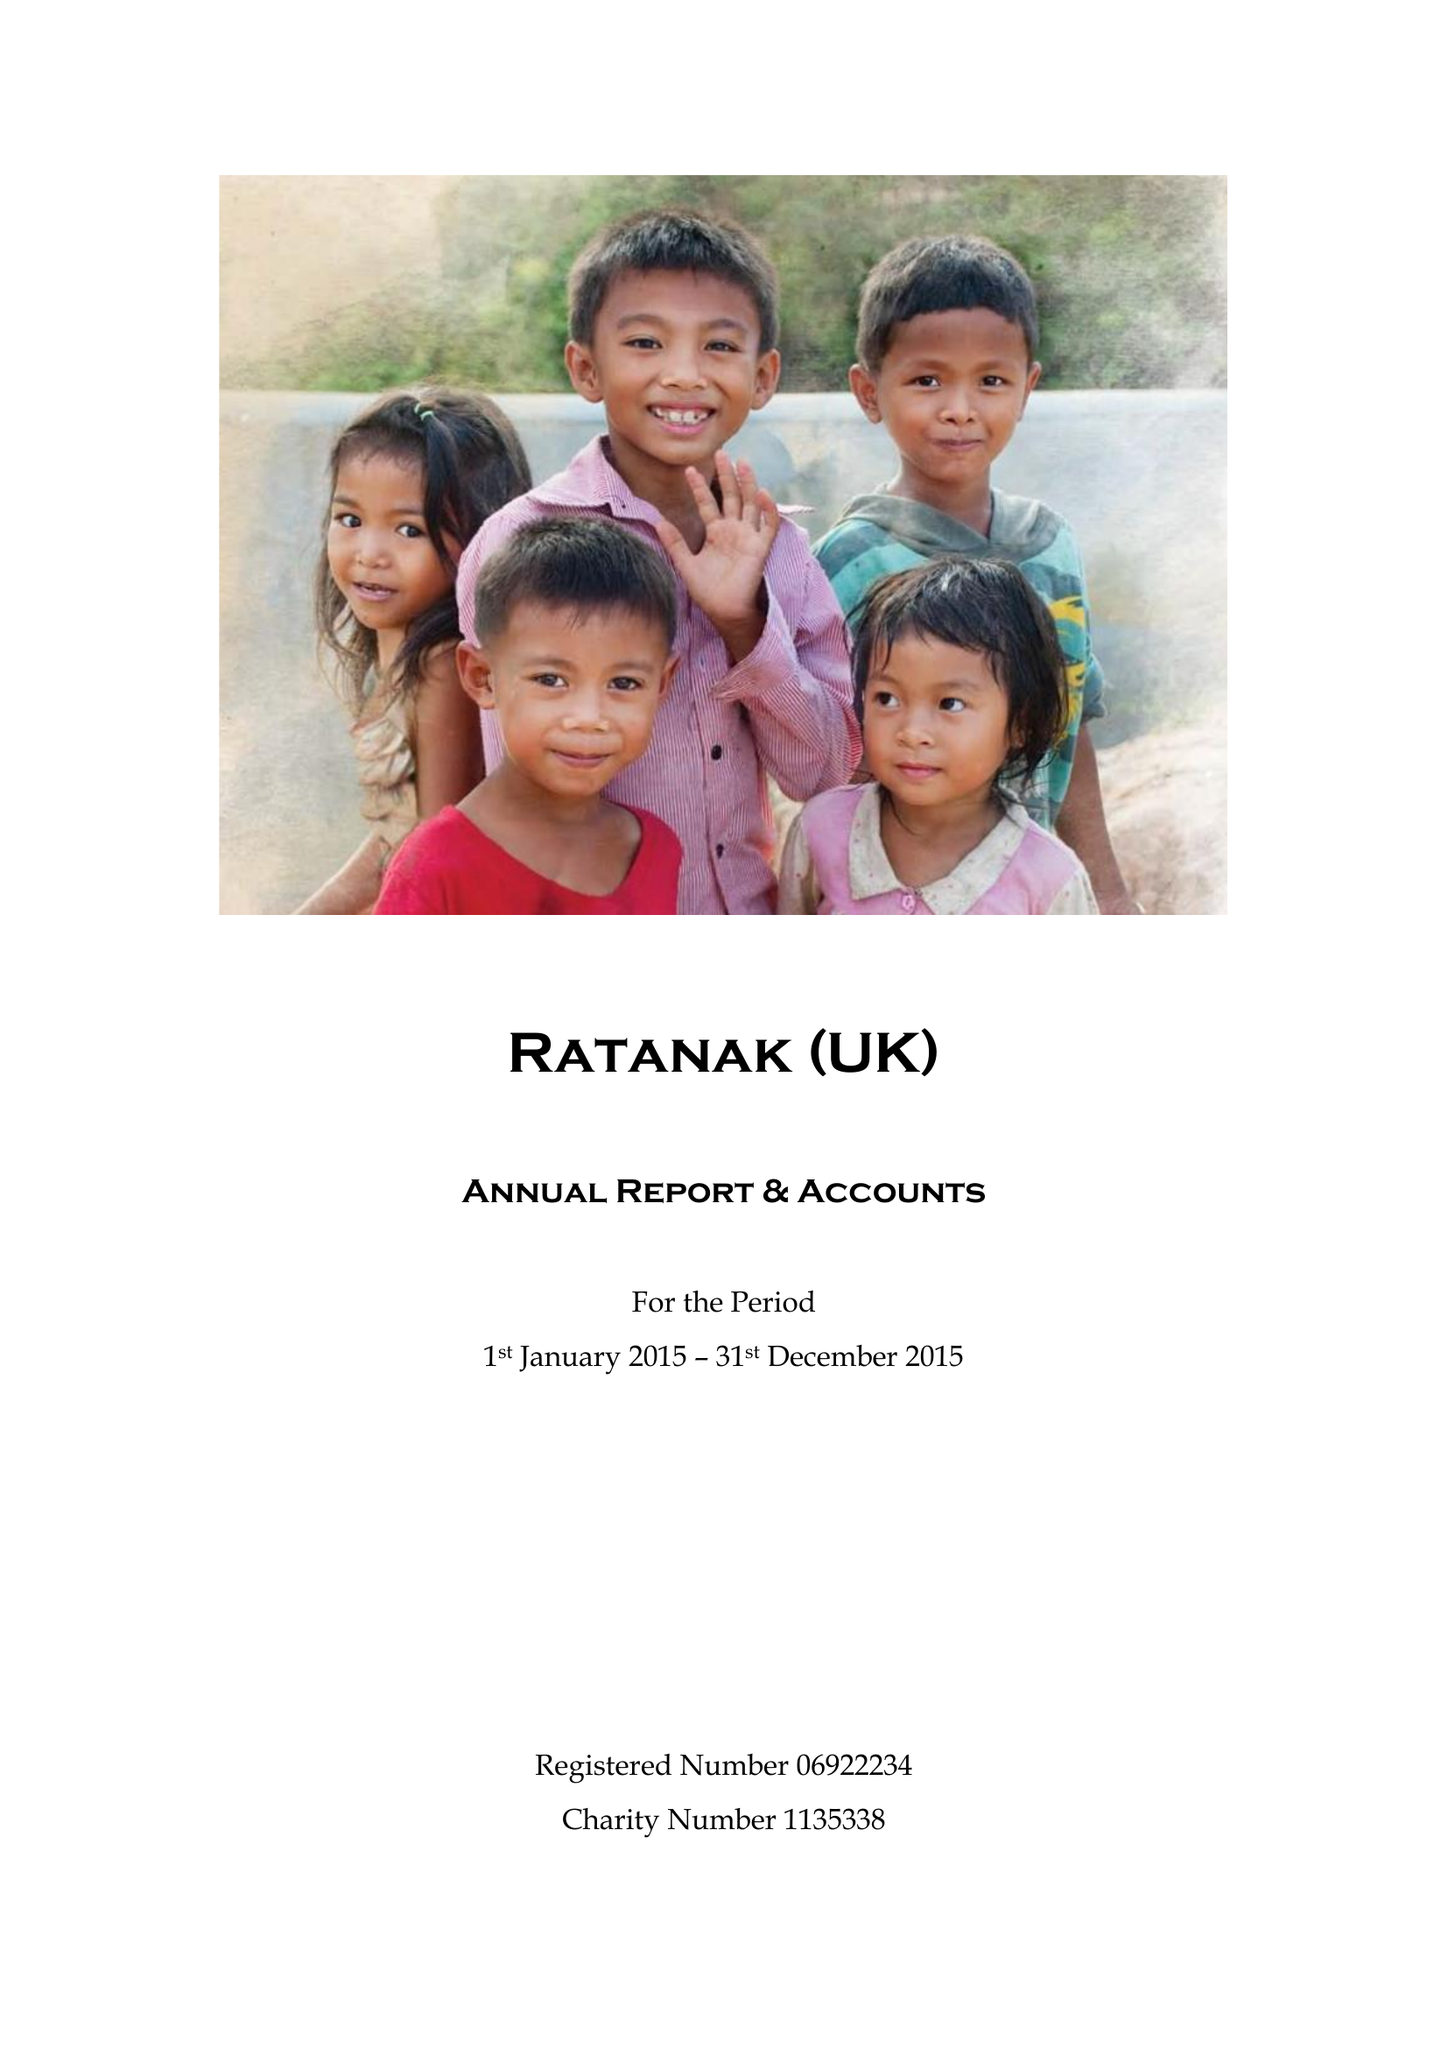What is the value for the address__street_line?
Answer the question using a single word or phrase. 10 ST HELENS CLOSE 